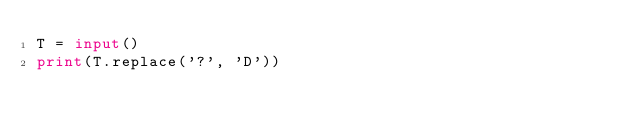<code> <loc_0><loc_0><loc_500><loc_500><_Python_>T = input()
print(T.replace('?', 'D'))</code> 